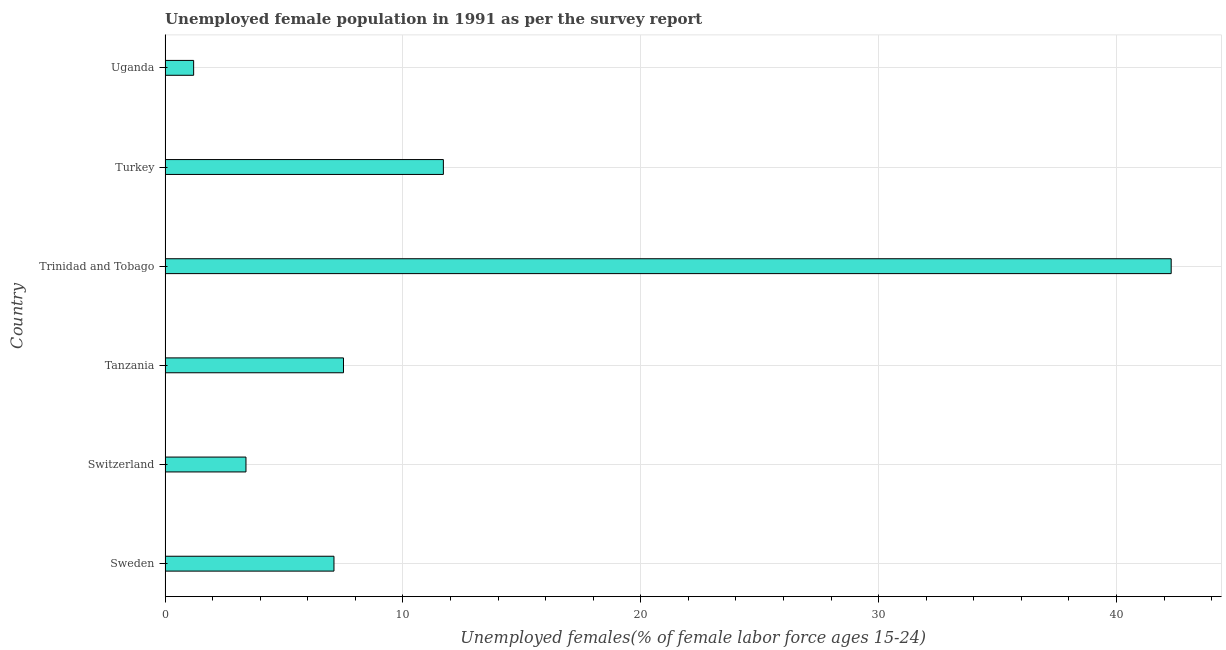Does the graph contain any zero values?
Provide a succinct answer. No. What is the title of the graph?
Provide a succinct answer. Unemployed female population in 1991 as per the survey report. What is the label or title of the X-axis?
Your answer should be compact. Unemployed females(% of female labor force ages 15-24). What is the unemployed female youth in Uganda?
Your response must be concise. 1.2. Across all countries, what is the maximum unemployed female youth?
Provide a succinct answer. 42.3. Across all countries, what is the minimum unemployed female youth?
Keep it short and to the point. 1.2. In which country was the unemployed female youth maximum?
Provide a short and direct response. Trinidad and Tobago. In which country was the unemployed female youth minimum?
Your answer should be compact. Uganda. What is the sum of the unemployed female youth?
Ensure brevity in your answer.  73.2. What is the median unemployed female youth?
Provide a short and direct response. 7.3. In how many countries, is the unemployed female youth greater than 22 %?
Offer a terse response. 1. What is the ratio of the unemployed female youth in Trinidad and Tobago to that in Uganda?
Your answer should be compact. 35.25. Is the unemployed female youth in Sweden less than that in Trinidad and Tobago?
Ensure brevity in your answer.  Yes. What is the difference between the highest and the second highest unemployed female youth?
Offer a very short reply. 30.6. What is the difference between the highest and the lowest unemployed female youth?
Your answer should be very brief. 41.1. What is the difference between two consecutive major ticks on the X-axis?
Provide a succinct answer. 10. What is the Unemployed females(% of female labor force ages 15-24) of Sweden?
Offer a very short reply. 7.1. What is the Unemployed females(% of female labor force ages 15-24) in Switzerland?
Offer a very short reply. 3.4. What is the Unemployed females(% of female labor force ages 15-24) of Tanzania?
Give a very brief answer. 7.5. What is the Unemployed females(% of female labor force ages 15-24) in Trinidad and Tobago?
Offer a very short reply. 42.3. What is the Unemployed females(% of female labor force ages 15-24) of Turkey?
Make the answer very short. 11.7. What is the Unemployed females(% of female labor force ages 15-24) in Uganda?
Provide a short and direct response. 1.2. What is the difference between the Unemployed females(% of female labor force ages 15-24) in Sweden and Switzerland?
Your answer should be compact. 3.7. What is the difference between the Unemployed females(% of female labor force ages 15-24) in Sweden and Tanzania?
Your response must be concise. -0.4. What is the difference between the Unemployed females(% of female labor force ages 15-24) in Sweden and Trinidad and Tobago?
Ensure brevity in your answer.  -35.2. What is the difference between the Unemployed females(% of female labor force ages 15-24) in Sweden and Turkey?
Ensure brevity in your answer.  -4.6. What is the difference between the Unemployed females(% of female labor force ages 15-24) in Switzerland and Trinidad and Tobago?
Ensure brevity in your answer.  -38.9. What is the difference between the Unemployed females(% of female labor force ages 15-24) in Tanzania and Trinidad and Tobago?
Make the answer very short. -34.8. What is the difference between the Unemployed females(% of female labor force ages 15-24) in Trinidad and Tobago and Turkey?
Ensure brevity in your answer.  30.6. What is the difference between the Unemployed females(% of female labor force ages 15-24) in Trinidad and Tobago and Uganda?
Offer a terse response. 41.1. What is the ratio of the Unemployed females(% of female labor force ages 15-24) in Sweden to that in Switzerland?
Provide a short and direct response. 2.09. What is the ratio of the Unemployed females(% of female labor force ages 15-24) in Sweden to that in Tanzania?
Your response must be concise. 0.95. What is the ratio of the Unemployed females(% of female labor force ages 15-24) in Sweden to that in Trinidad and Tobago?
Ensure brevity in your answer.  0.17. What is the ratio of the Unemployed females(% of female labor force ages 15-24) in Sweden to that in Turkey?
Offer a terse response. 0.61. What is the ratio of the Unemployed females(% of female labor force ages 15-24) in Sweden to that in Uganda?
Provide a short and direct response. 5.92. What is the ratio of the Unemployed females(% of female labor force ages 15-24) in Switzerland to that in Tanzania?
Offer a very short reply. 0.45. What is the ratio of the Unemployed females(% of female labor force ages 15-24) in Switzerland to that in Trinidad and Tobago?
Your answer should be compact. 0.08. What is the ratio of the Unemployed females(% of female labor force ages 15-24) in Switzerland to that in Turkey?
Your response must be concise. 0.29. What is the ratio of the Unemployed females(% of female labor force ages 15-24) in Switzerland to that in Uganda?
Your response must be concise. 2.83. What is the ratio of the Unemployed females(% of female labor force ages 15-24) in Tanzania to that in Trinidad and Tobago?
Ensure brevity in your answer.  0.18. What is the ratio of the Unemployed females(% of female labor force ages 15-24) in Tanzania to that in Turkey?
Offer a very short reply. 0.64. What is the ratio of the Unemployed females(% of female labor force ages 15-24) in Tanzania to that in Uganda?
Your answer should be very brief. 6.25. What is the ratio of the Unemployed females(% of female labor force ages 15-24) in Trinidad and Tobago to that in Turkey?
Offer a terse response. 3.62. What is the ratio of the Unemployed females(% of female labor force ages 15-24) in Trinidad and Tobago to that in Uganda?
Provide a short and direct response. 35.25. What is the ratio of the Unemployed females(% of female labor force ages 15-24) in Turkey to that in Uganda?
Your answer should be very brief. 9.75. 